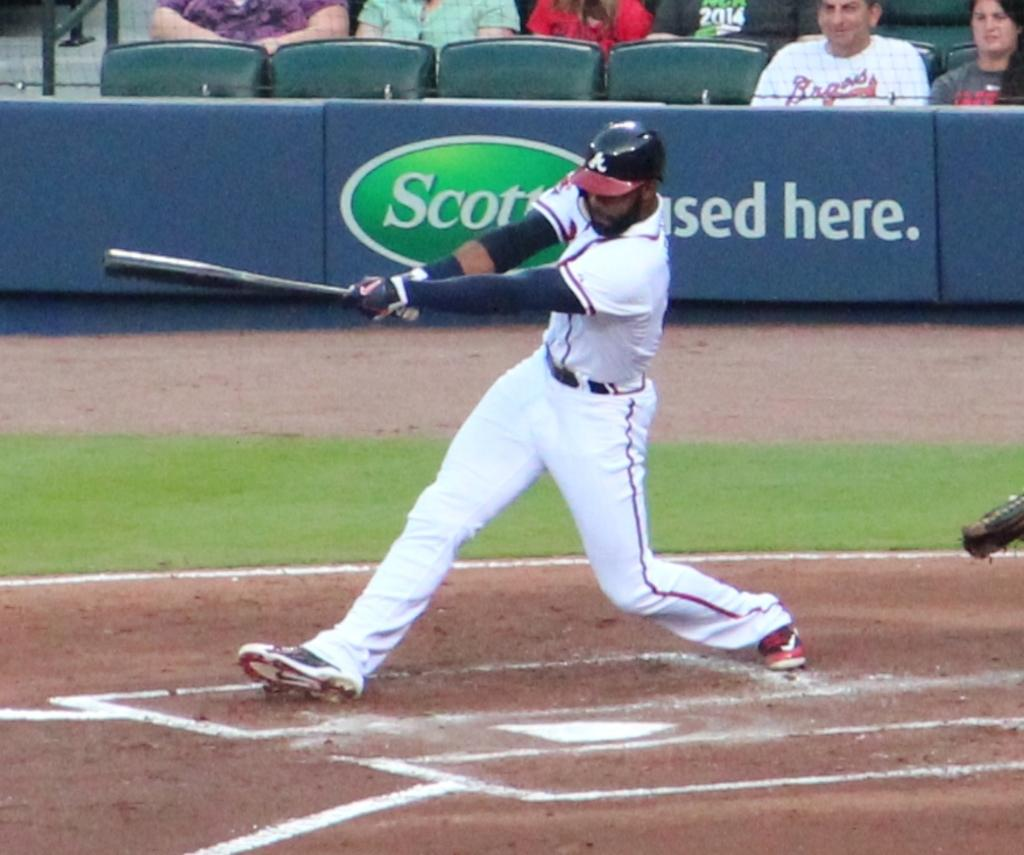Provide a one-sentence caption for the provided image. A baseball player swings the bat in front of a sign for Scott's-used here. 